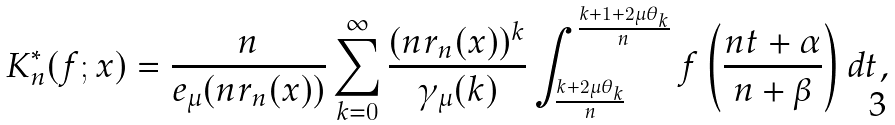Convert formula to latex. <formula><loc_0><loc_0><loc_500><loc_500>K _ { n } ^ { \ast } ( f ; x ) = \frac { n } { e _ { \mu } ( n r _ { n } ( x ) ) } \sum _ { k = 0 } ^ { \infty } \frac { ( n r _ { n } ( x ) ) ^ { k } } { \gamma _ { \mu } ( k ) } \int _ { \frac { k + 2 \mu \theta _ { k } } { n } } ^ { \frac { k + 1 + 2 \mu \theta _ { k } } { n } } f \left ( \frac { n t + \alpha } { n + \beta } \right ) d t ,</formula> 